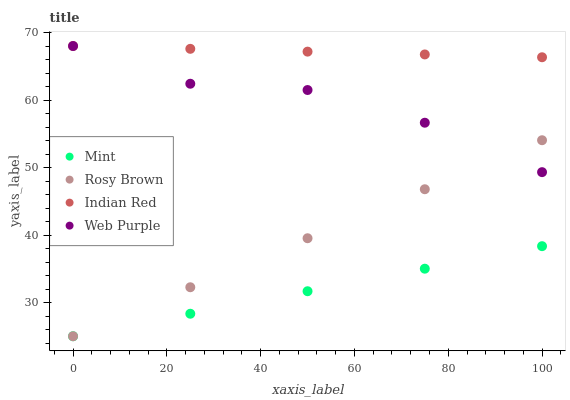Does Mint have the minimum area under the curve?
Answer yes or no. Yes. Does Indian Red have the maximum area under the curve?
Answer yes or no. Yes. Does Rosy Brown have the minimum area under the curve?
Answer yes or no. No. Does Rosy Brown have the maximum area under the curve?
Answer yes or no. No. Is Mint the smoothest?
Answer yes or no. Yes. Is Web Purple the roughest?
Answer yes or no. Yes. Is Rosy Brown the smoothest?
Answer yes or no. No. Is Rosy Brown the roughest?
Answer yes or no. No. Does Rosy Brown have the lowest value?
Answer yes or no. Yes. Does Indian Red have the lowest value?
Answer yes or no. No. Does Indian Red have the highest value?
Answer yes or no. Yes. Does Rosy Brown have the highest value?
Answer yes or no. No. Is Mint less than Web Purple?
Answer yes or no. Yes. Is Indian Red greater than Mint?
Answer yes or no. Yes. Does Web Purple intersect Indian Red?
Answer yes or no. Yes. Is Web Purple less than Indian Red?
Answer yes or no. No. Is Web Purple greater than Indian Red?
Answer yes or no. No. Does Mint intersect Web Purple?
Answer yes or no. No. 